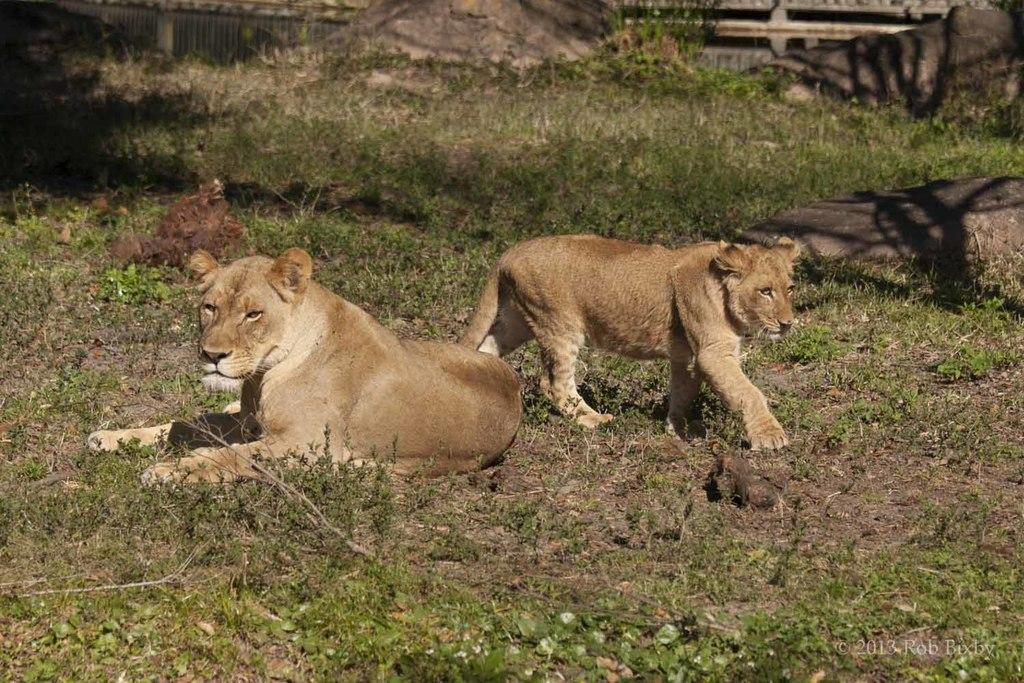What type of animals can be seen in the image? There are two animals on the ground in the image. What type of terrain is visible in the image? Grass and rocks are visible in the image. What can be seen in the background of the image? There is a fence in the background of the image. What type of cable can be seen connecting the animals in the image? There is no cable connecting the animals in the image. What shape is formed by the animals in the image? The animals in the image do not form a specific shape, such as a circle. 